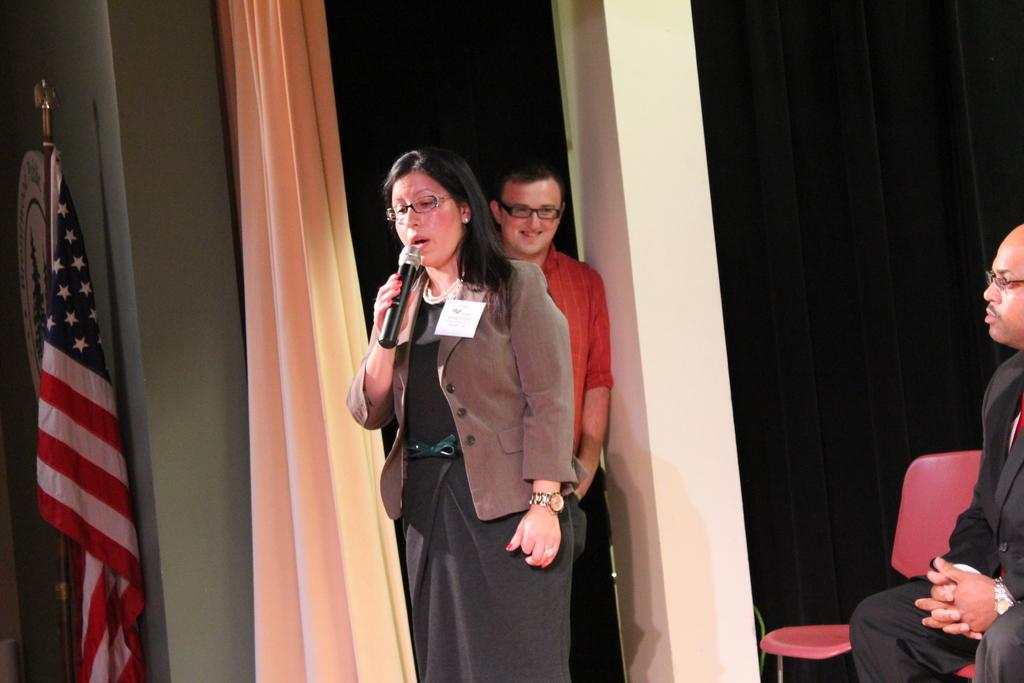What is the position of the person in the image? There is a person sitting on a chair in the image. How many people are standing in the image? There are two people standing in the image. What is one person holding in the image? One person is holding a microphone. What architectural feature can be seen in the image? There is a pillar in the image. What type of fabric is present in the image? There is a curtain in the image. Where is the flag located in the image? The flag is near a wall in the image. What type of drink is the person holding in the image? There is no drink present in the image; the person is holding a microphone. How does the person's anger affect the image? There is no indication of anger in the image, as the person is sitting calmly on a chair. 